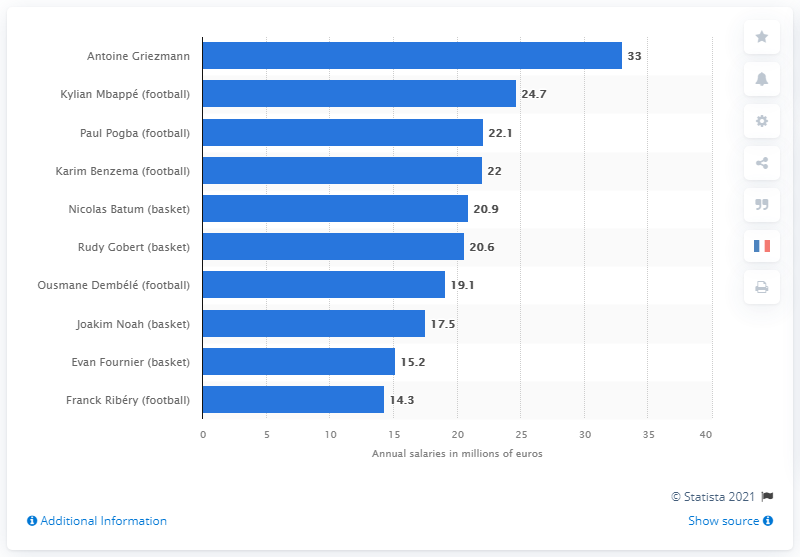Draw attention to some important aspects in this diagram. Antoine Griezmann's annual salary was approximately 33 million dollars. 